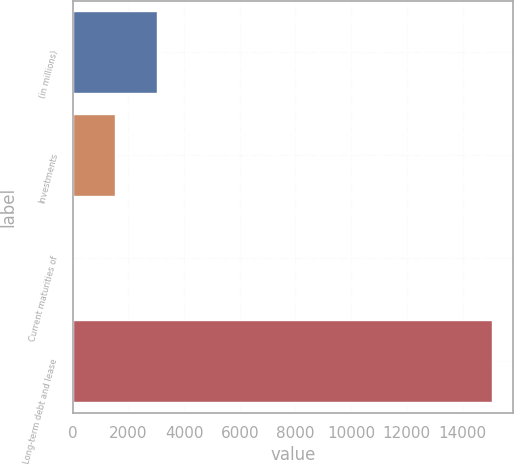<chart> <loc_0><loc_0><loc_500><loc_500><bar_chart><fcel>(in millions)<fcel>Investments<fcel>Current maturities of<fcel>Long-term debt and lease<nl><fcel>3030.8<fcel>1526.4<fcel>22<fcel>15066<nl></chart> 